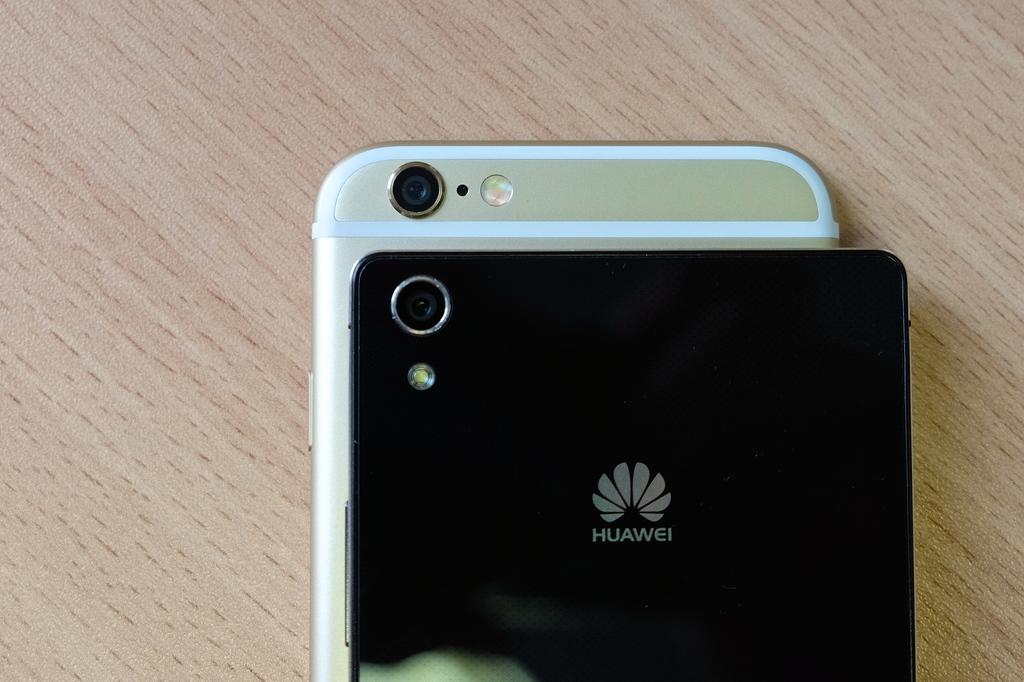What kind of phone is the black one?
Make the answer very short. Huawei. 